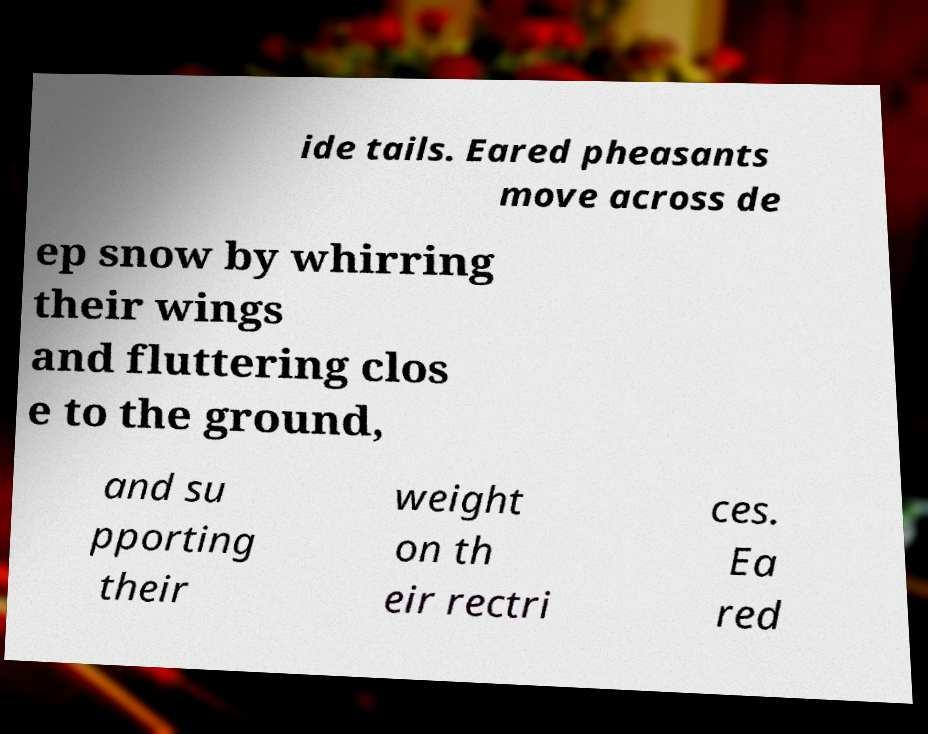For documentation purposes, I need the text within this image transcribed. Could you provide that? ide tails. Eared pheasants move across de ep snow by whirring their wings and fluttering clos e to the ground, and su pporting their weight on th eir rectri ces. Ea red 